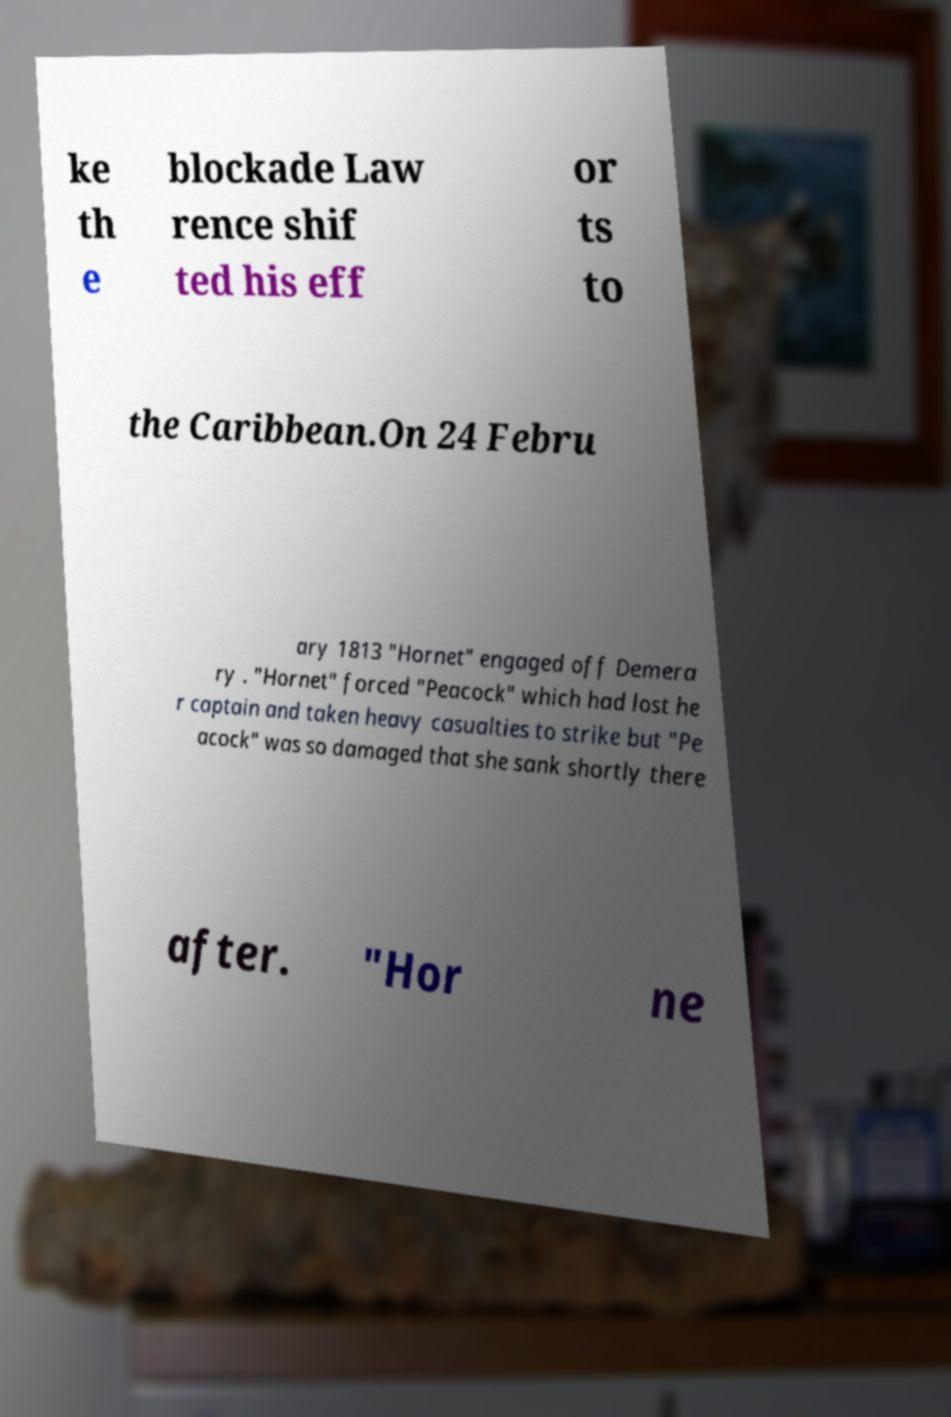Could you extract and type out the text from this image? ke th e blockade Law rence shif ted his eff or ts to the Caribbean.On 24 Febru ary 1813 "Hornet" engaged off Demera ry . "Hornet" forced "Peacock" which had lost he r captain and taken heavy casualties to strike but "Pe acock" was so damaged that she sank shortly there after. "Hor ne 